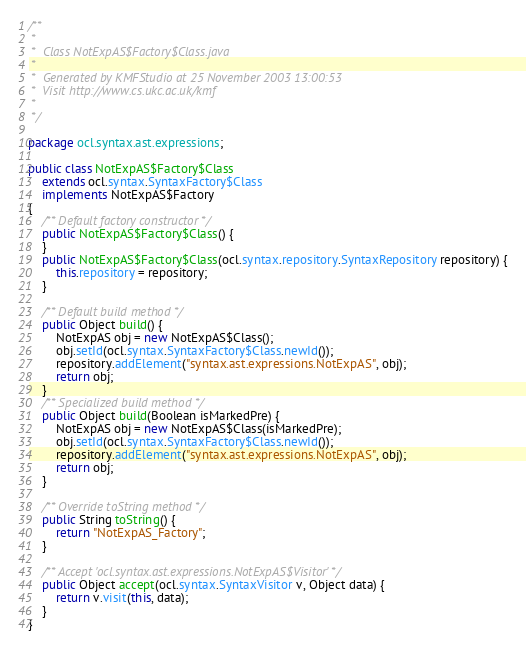Convert code to text. <code><loc_0><loc_0><loc_500><loc_500><_Java_>/**
 *
 *  Class NotExpAS$Factory$Class.java
 *
 *  Generated by KMFStudio at 25 November 2003 13:00:53
 *  Visit http://www.cs.ukc.ac.uk/kmf
 *
 */

package ocl.syntax.ast.expressions;

public class NotExpAS$Factory$Class
	extends ocl.syntax.SyntaxFactory$Class
	implements NotExpAS$Factory
{
	/** Default factory constructor */
	public NotExpAS$Factory$Class() {
	}
	public NotExpAS$Factory$Class(ocl.syntax.repository.SyntaxRepository repository) {
		this.repository = repository;
	}

	/** Default build method */
	public Object build() {
		NotExpAS obj = new NotExpAS$Class();
		obj.setId(ocl.syntax.SyntaxFactory$Class.newId());
		repository.addElement("syntax.ast.expressions.NotExpAS", obj);
		return obj;
	}
	/** Specialized build method */
	public Object build(Boolean isMarkedPre) {
		NotExpAS obj = new NotExpAS$Class(isMarkedPre);
		obj.setId(ocl.syntax.SyntaxFactory$Class.newId());
		repository.addElement("syntax.ast.expressions.NotExpAS", obj);
		return obj;
	}

	/** Override toString method */
	public String toString() {
		return "NotExpAS_Factory";
	}

	/** Accept 'ocl.syntax.ast.expressions.NotExpAS$Visitor' */
	public Object accept(ocl.syntax.SyntaxVisitor v, Object data) {
		return v.visit(this, data);
	}
}
</code> 